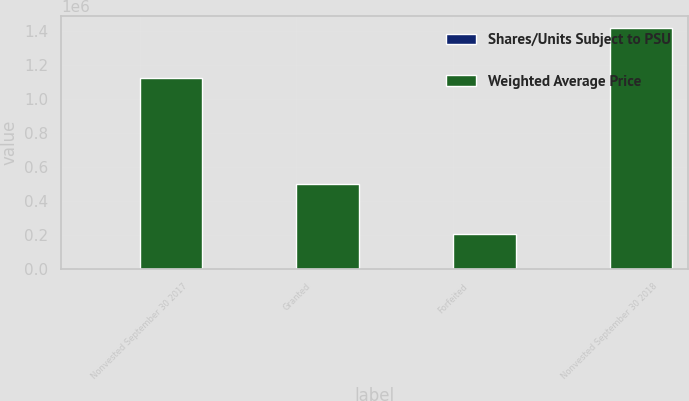Convert chart. <chart><loc_0><loc_0><loc_500><loc_500><stacked_bar_chart><ecel><fcel>Nonvested September 30 2017<fcel>Granted<fcel>Forfeited<fcel>Nonvested September 30 2018<nl><fcel>Shares/Units Subject to PSU<fcel>43.24<fcel>37.36<fcel>43.97<fcel>41.07<nl><fcel>Weighted Average Price<fcel>1.11939e+06<fcel>496478<fcel>203576<fcel>1.41229e+06<nl></chart> 